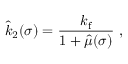<formula> <loc_0><loc_0><loc_500><loc_500>\hat { k } _ { 2 } ( \sigma ) = \frac { k _ { f } } { 1 + \hat { \mu } ( \sigma ) } \ ,</formula> 